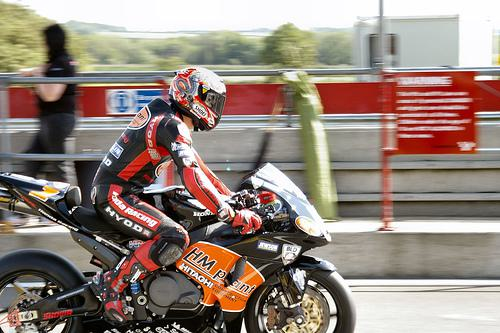Would there be a motorbike in the image once the motorbike has been removed from the scence? No 